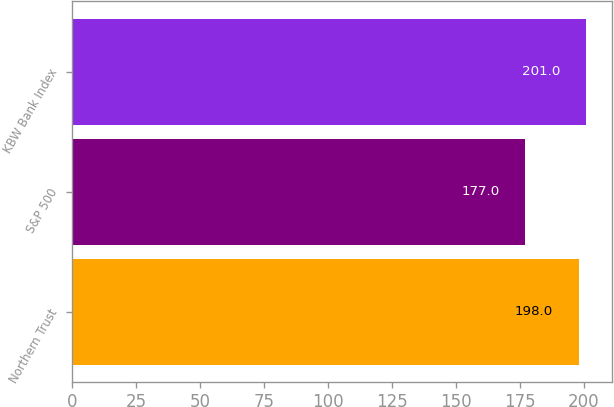Convert chart to OTSL. <chart><loc_0><loc_0><loc_500><loc_500><bar_chart><fcel>Northern Trust<fcel>S&P 500<fcel>KBW Bank Index<nl><fcel>198<fcel>177<fcel>201<nl></chart> 